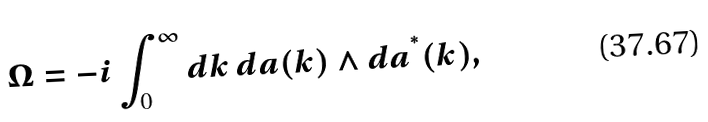<formula> <loc_0><loc_0><loc_500><loc_500>\Omega = - i \int _ { 0 } ^ { \infty } d k \, { d } a ( k ) \wedge { d } a ^ { ^ { * } } ( k ) ,</formula> 